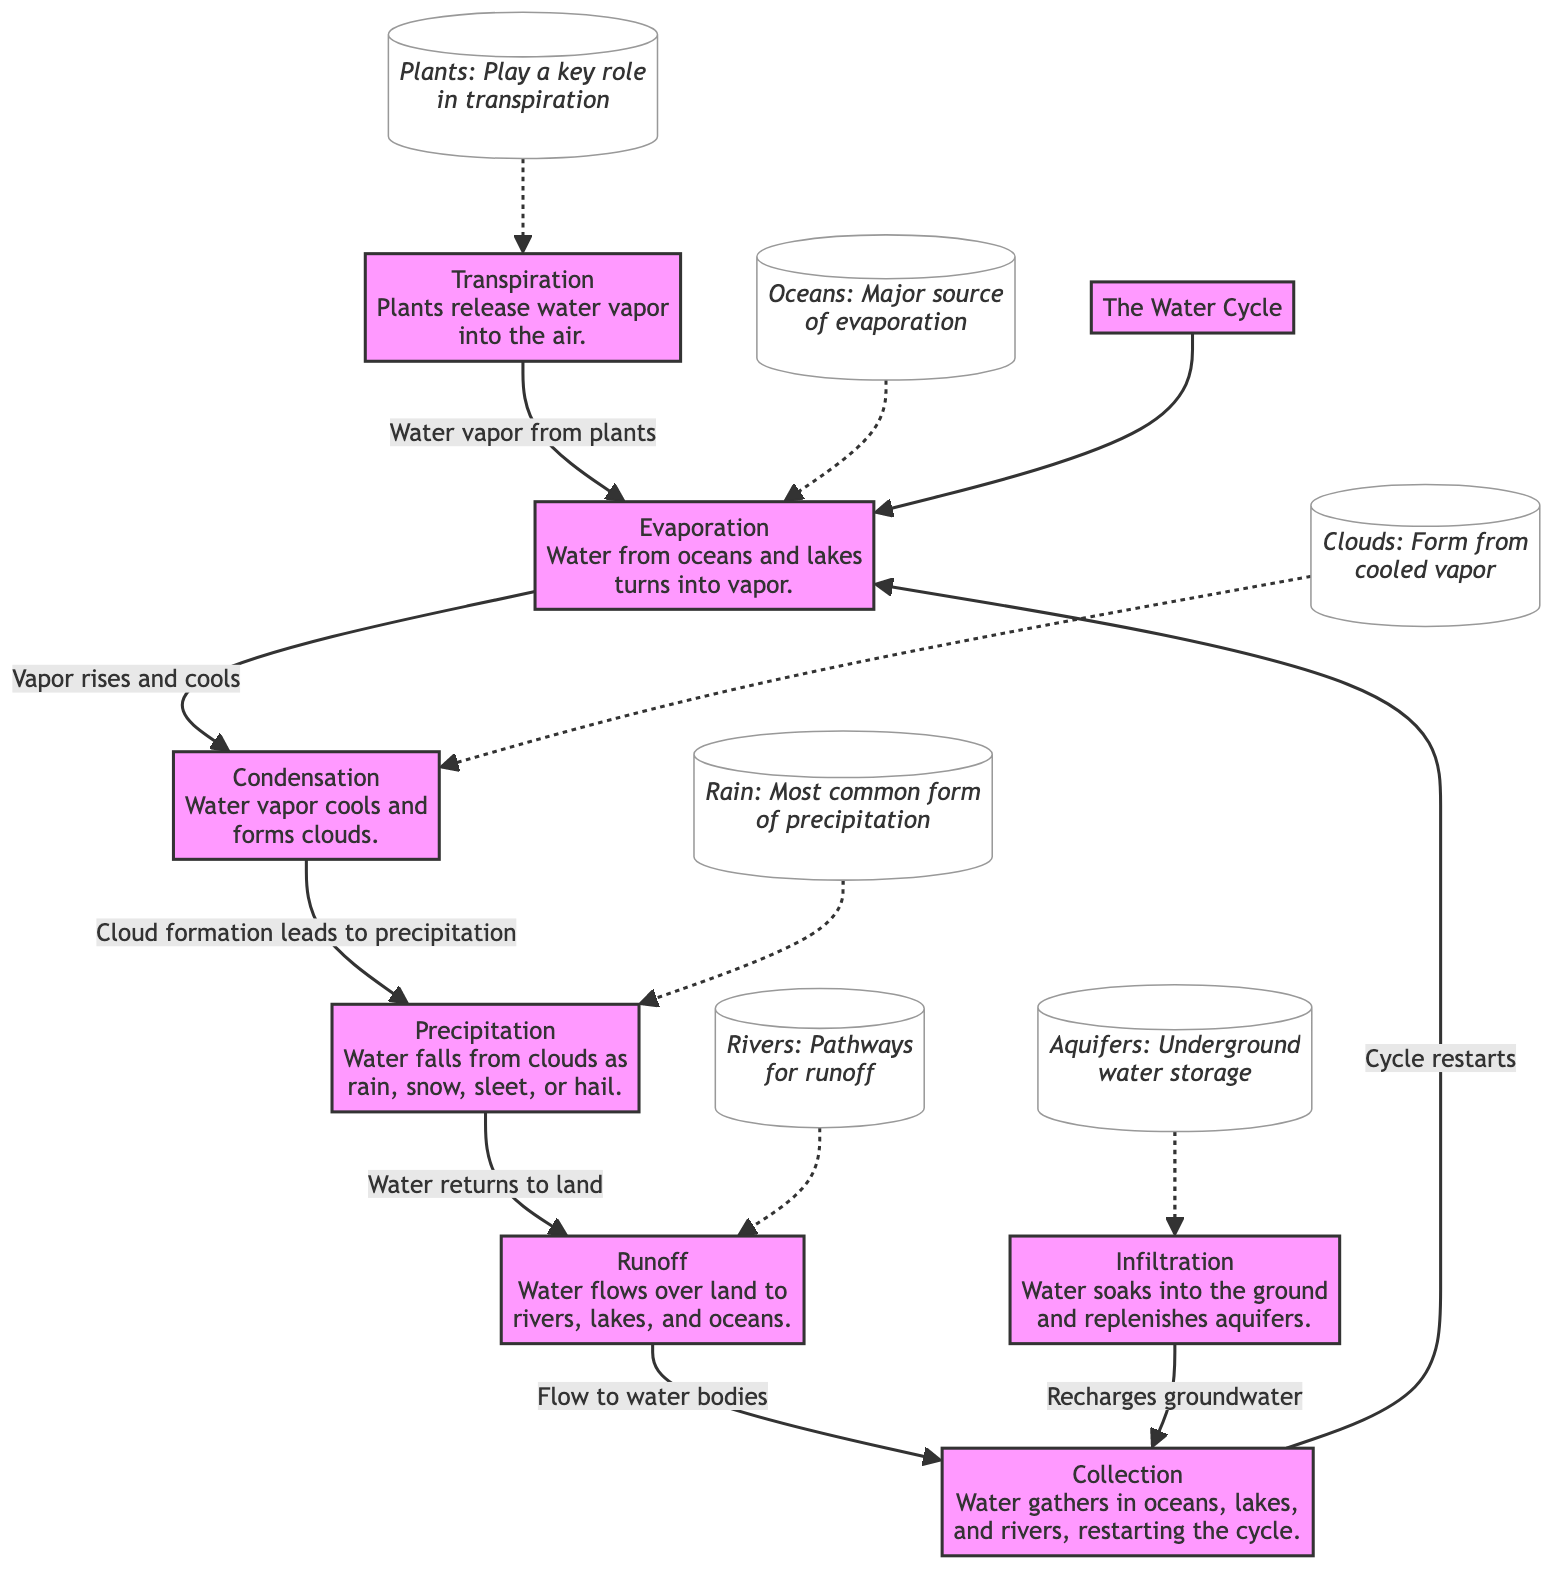What is the first step of the water cycle? The diagram shows "Evaporation" as the first process in the water cycle.
Answer: Evaporation How many main processes are depicted in the water cycle? By counting each distinct node in the diagram, there are six main processes: Evaporation, Condensation, Precipitation, Runoff, Infiltration, and Transpiration.
Answer: Six Which process leads to the formation of clouds? The diagram indicates that "Condensation" is the process where water vapor cools and forms clouds.
Answer: Condensation What is the final step before the cycle restarts? The diagram shows that "Collection" is the last step before the cycle of water restarts.
Answer: Collection Which process recharges groundwater? According to the diagram, "Infiltration" is the process that soaks water into the ground and replenishes aquifers.
Answer: Infiltration What are the two processes that involve the movement of vapor? "Evaporation" (where water turns into vapor) and "Transpiration" (where plants release water vapor) are the two processes that involve moving vapor.
Answer: Evaporation and Transpiration What falls from clouds as precipitation? The diagram specifies that water falls from clouds in various forms, including rain, snow, sleet, or hail.
Answer: Rain, snow, sleet, or hail Which component is a major source of evaporation? The diagram identifies "Oceans" as the major source of evaporation.
Answer: Oceans What connects runoff to water bodies? The diagram indicates that runoff is the flow of water that connects directly to rivers, lakes, and oceans.
Answer: Rivers, lakes, and oceans 